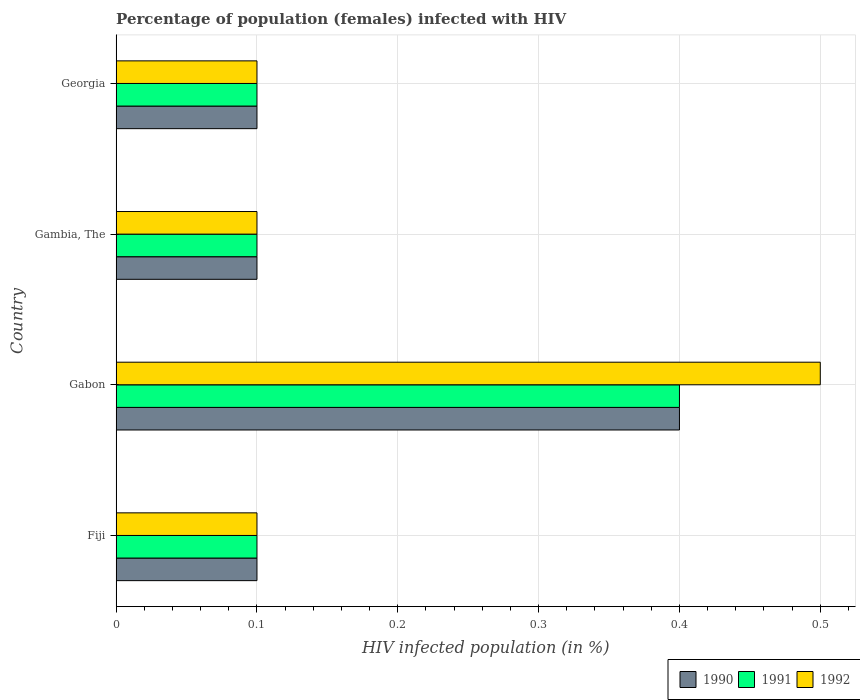How many different coloured bars are there?
Provide a short and direct response. 3. How many groups of bars are there?
Keep it short and to the point. 4. Are the number of bars per tick equal to the number of legend labels?
Make the answer very short. Yes. Are the number of bars on each tick of the Y-axis equal?
Ensure brevity in your answer.  Yes. What is the label of the 3rd group of bars from the top?
Give a very brief answer. Gabon. In how many cases, is the number of bars for a given country not equal to the number of legend labels?
Ensure brevity in your answer.  0. Across all countries, what is the maximum percentage of HIV infected female population in 1992?
Ensure brevity in your answer.  0.5. In which country was the percentage of HIV infected female population in 1992 maximum?
Ensure brevity in your answer.  Gabon. In which country was the percentage of HIV infected female population in 1992 minimum?
Your response must be concise. Fiji. What is the total percentage of HIV infected female population in 1992 in the graph?
Offer a terse response. 0.8. What is the difference between the percentage of HIV infected female population in 1992 in Gambia, The and that in Georgia?
Give a very brief answer. 0. What is the difference between the percentage of HIV infected female population in 1990 in Gabon and the percentage of HIV infected female population in 1992 in Georgia?
Your response must be concise. 0.3. What is the average percentage of HIV infected female population in 1990 per country?
Ensure brevity in your answer.  0.17. What is the difference between the percentage of HIV infected female population in 1990 and percentage of HIV infected female population in 1992 in Gambia, The?
Provide a short and direct response. 0. What is the ratio of the percentage of HIV infected female population in 1991 in Fiji to that in Gabon?
Offer a very short reply. 0.25. Is the percentage of HIV infected female population in 1990 in Gambia, The less than that in Georgia?
Provide a succinct answer. No. What is the difference between the highest and the second highest percentage of HIV infected female population in 1991?
Your response must be concise. 0.3. What does the 2nd bar from the bottom in Georgia represents?
Give a very brief answer. 1991. Is it the case that in every country, the sum of the percentage of HIV infected female population in 1990 and percentage of HIV infected female population in 1992 is greater than the percentage of HIV infected female population in 1991?
Offer a terse response. Yes. How many bars are there?
Provide a short and direct response. 12. Are all the bars in the graph horizontal?
Offer a terse response. Yes. How many countries are there in the graph?
Give a very brief answer. 4. What is the difference between two consecutive major ticks on the X-axis?
Offer a very short reply. 0.1. Are the values on the major ticks of X-axis written in scientific E-notation?
Your answer should be compact. No. Does the graph contain grids?
Make the answer very short. Yes. Where does the legend appear in the graph?
Your answer should be very brief. Bottom right. What is the title of the graph?
Your response must be concise. Percentage of population (females) infected with HIV. Does "1960" appear as one of the legend labels in the graph?
Keep it short and to the point. No. What is the label or title of the X-axis?
Provide a short and direct response. HIV infected population (in %). What is the label or title of the Y-axis?
Make the answer very short. Country. What is the HIV infected population (in %) of 1991 in Fiji?
Offer a very short reply. 0.1. What is the HIV infected population (in %) of 1992 in Fiji?
Your answer should be very brief. 0.1. What is the HIV infected population (in %) in 1990 in Gabon?
Ensure brevity in your answer.  0.4. What is the HIV infected population (in %) in 1992 in Gabon?
Your response must be concise. 0.5. What is the HIV infected population (in %) of 1992 in Georgia?
Make the answer very short. 0.1. Across all countries, what is the maximum HIV infected population (in %) of 1991?
Keep it short and to the point. 0.4. Across all countries, what is the maximum HIV infected population (in %) of 1992?
Your answer should be compact. 0.5. Across all countries, what is the minimum HIV infected population (in %) of 1990?
Make the answer very short. 0.1. Across all countries, what is the minimum HIV infected population (in %) of 1991?
Your answer should be compact. 0.1. Across all countries, what is the minimum HIV infected population (in %) in 1992?
Your answer should be very brief. 0.1. What is the difference between the HIV infected population (in %) of 1990 in Fiji and that in Gabon?
Offer a terse response. -0.3. What is the difference between the HIV infected population (in %) of 1992 in Fiji and that in Gabon?
Offer a terse response. -0.4. What is the difference between the HIV infected population (in %) of 1992 in Fiji and that in Gambia, The?
Make the answer very short. 0. What is the difference between the HIV infected population (in %) of 1990 in Fiji and that in Georgia?
Make the answer very short. 0. What is the difference between the HIV infected population (in %) of 1991 in Fiji and that in Georgia?
Provide a succinct answer. 0. What is the difference between the HIV infected population (in %) of 1992 in Fiji and that in Georgia?
Make the answer very short. 0. What is the difference between the HIV infected population (in %) of 1991 in Gabon and that in Georgia?
Give a very brief answer. 0.3. What is the difference between the HIV infected population (in %) in 1990 in Gambia, The and that in Georgia?
Your answer should be compact. 0. What is the difference between the HIV infected population (in %) in 1991 in Gambia, The and that in Georgia?
Ensure brevity in your answer.  0. What is the difference between the HIV infected population (in %) of 1992 in Gambia, The and that in Georgia?
Your answer should be compact. 0. What is the difference between the HIV infected population (in %) of 1990 in Fiji and the HIV infected population (in %) of 1992 in Gabon?
Give a very brief answer. -0.4. What is the difference between the HIV infected population (in %) in 1990 in Fiji and the HIV infected population (in %) in 1991 in Georgia?
Provide a succinct answer. 0. What is the difference between the HIV infected population (in %) of 1991 in Fiji and the HIV infected population (in %) of 1992 in Georgia?
Offer a terse response. 0. What is the difference between the HIV infected population (in %) in 1990 in Gabon and the HIV infected population (in %) in 1992 in Georgia?
Provide a succinct answer. 0.3. What is the average HIV infected population (in %) in 1990 per country?
Your answer should be very brief. 0.17. What is the average HIV infected population (in %) of 1991 per country?
Offer a very short reply. 0.17. What is the average HIV infected population (in %) in 1992 per country?
Provide a succinct answer. 0.2. What is the difference between the HIV infected population (in %) of 1991 and HIV infected population (in %) of 1992 in Fiji?
Offer a very short reply. 0. What is the difference between the HIV infected population (in %) in 1990 and HIV infected population (in %) in 1991 in Gabon?
Give a very brief answer. 0. What is the difference between the HIV infected population (in %) of 1990 and HIV infected population (in %) of 1992 in Gabon?
Your answer should be compact. -0.1. What is the difference between the HIV infected population (in %) in 1991 and HIV infected population (in %) in 1992 in Gabon?
Ensure brevity in your answer.  -0.1. What is the difference between the HIV infected population (in %) of 1990 and HIV infected population (in %) of 1991 in Gambia, The?
Keep it short and to the point. 0. What is the difference between the HIV infected population (in %) in 1990 and HIV infected population (in %) in 1992 in Gambia, The?
Keep it short and to the point. 0. What is the difference between the HIV infected population (in %) of 1990 and HIV infected population (in %) of 1992 in Georgia?
Your answer should be very brief. 0. What is the difference between the HIV infected population (in %) in 1991 and HIV infected population (in %) in 1992 in Georgia?
Ensure brevity in your answer.  0. What is the ratio of the HIV infected population (in %) in 1990 in Fiji to that in Gabon?
Give a very brief answer. 0.25. What is the ratio of the HIV infected population (in %) in 1991 in Fiji to that in Gambia, The?
Provide a short and direct response. 1. What is the ratio of the HIV infected population (in %) of 1992 in Fiji to that in Gambia, The?
Your answer should be compact. 1. What is the ratio of the HIV infected population (in %) of 1990 in Fiji to that in Georgia?
Offer a terse response. 1. What is the ratio of the HIV infected population (in %) of 1991 in Gabon to that in Gambia, The?
Ensure brevity in your answer.  4. What is the ratio of the HIV infected population (in %) of 1992 in Gabon to that in Gambia, The?
Provide a succinct answer. 5. What is the ratio of the HIV infected population (in %) of 1991 in Gabon to that in Georgia?
Your response must be concise. 4. What is the ratio of the HIV infected population (in %) of 1991 in Gambia, The to that in Georgia?
Keep it short and to the point. 1. What is the difference between the highest and the second highest HIV infected population (in %) of 1990?
Offer a very short reply. 0.3. What is the difference between the highest and the lowest HIV infected population (in %) in 1990?
Your answer should be very brief. 0.3. What is the difference between the highest and the lowest HIV infected population (in %) of 1991?
Make the answer very short. 0.3. 